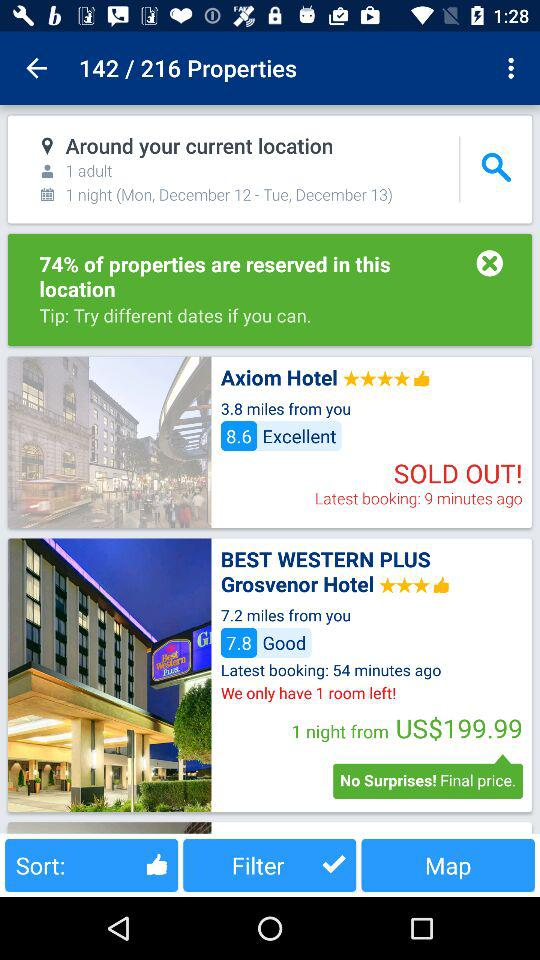What is the number of the current properties shown? The number of the current properties is 142. 